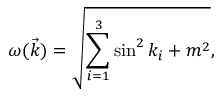Convert formula to latex. <formula><loc_0><loc_0><loc_500><loc_500>\omega ( \vec { k } ) = \sqrt { \sum _ { i = 1 } ^ { 3 } \sin ^ { 2 } k _ { i } + m ^ { 2 } } ,</formula> 